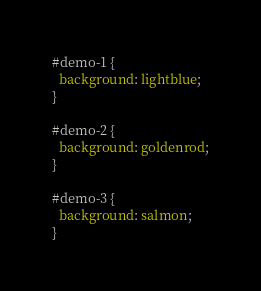Convert code to text. <code><loc_0><loc_0><loc_500><loc_500><_CSS_>#demo-1 {
  background: lightblue;
}

#demo-2 {
  background: goldenrod;
}

#demo-3 {
  background: salmon;
}
</code> 